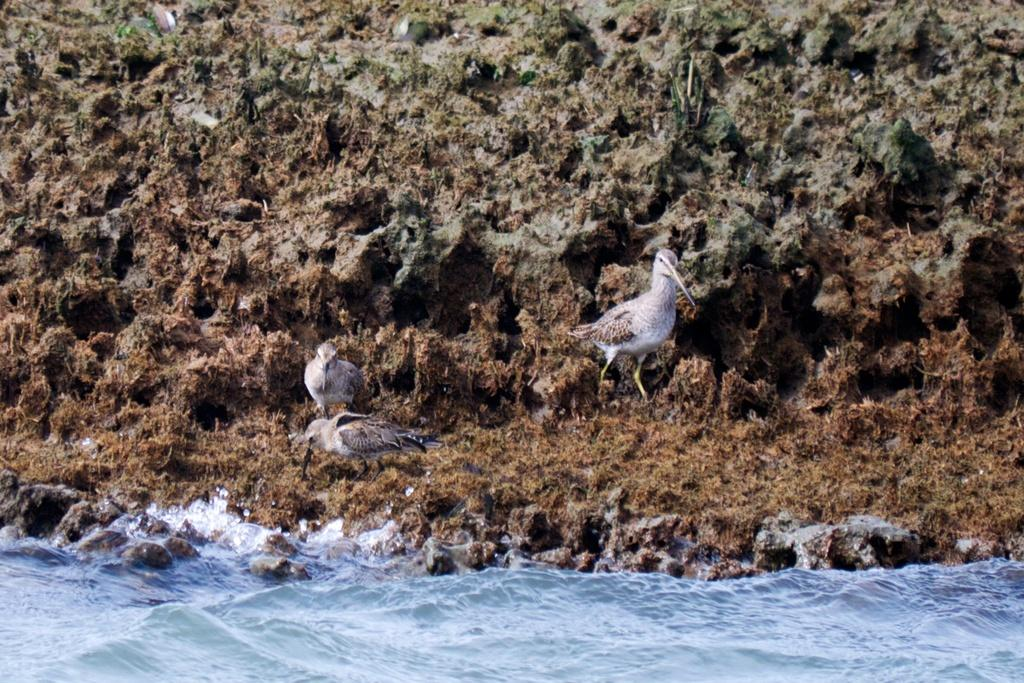What is the main subject of the image? The main subject of the image is a group of people standing in front of a building. Can you describe the building in the background? Unfortunately, the provided facts do not give any details about the building. How many people are present in the image? The provided facts do not specify the exact number of people, but there is a group of people in the image. What might the people be doing in the image? The provided facts do not give any information about the people's actions or activities. What type of organization is depicted in the image? There is no organization present in the image; it features a group of people standing in front of a building. What form does the fog take in the image? There is no fog present in the image. 